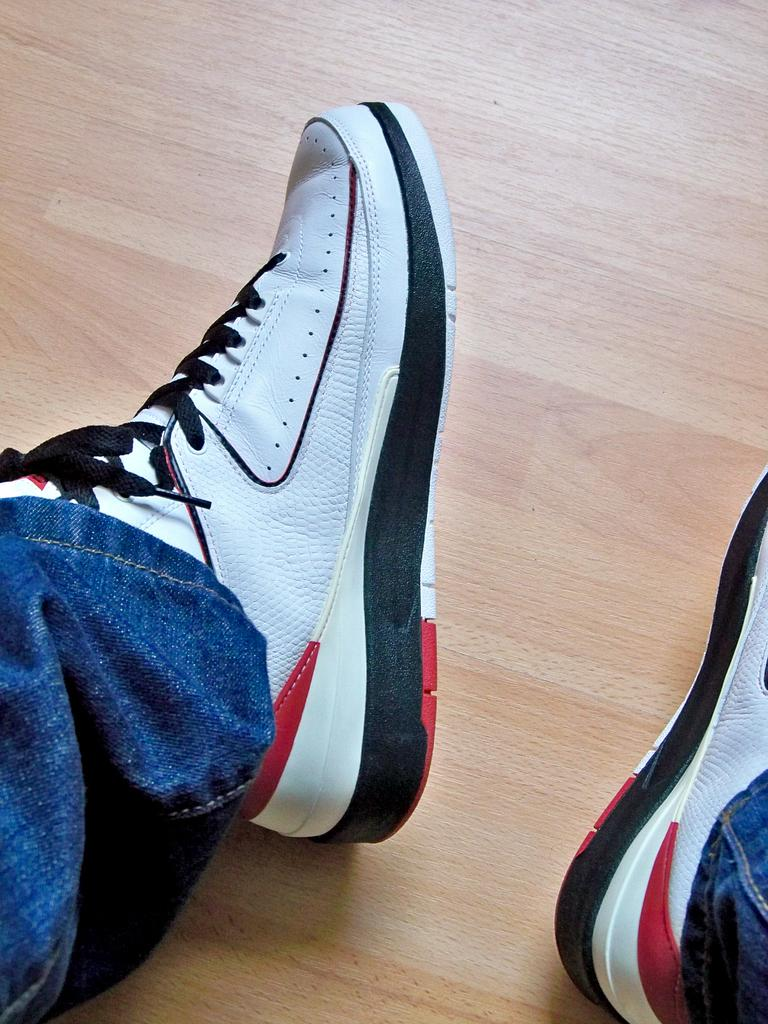What part of a person can be seen in the image? There are legs of a person in the image. What type of footwear is the person wearing? The person is wearing shoes. What type of surface is visible in the image? The image shows a floor. What type of vessel is being used by the person in the image? There is no vessel present in the image; it only shows the person's legs and shoes. Can you tell me where the playground is located in the image? There is no playground present in the image; it only shows the person's legs and shoes on a floor. 